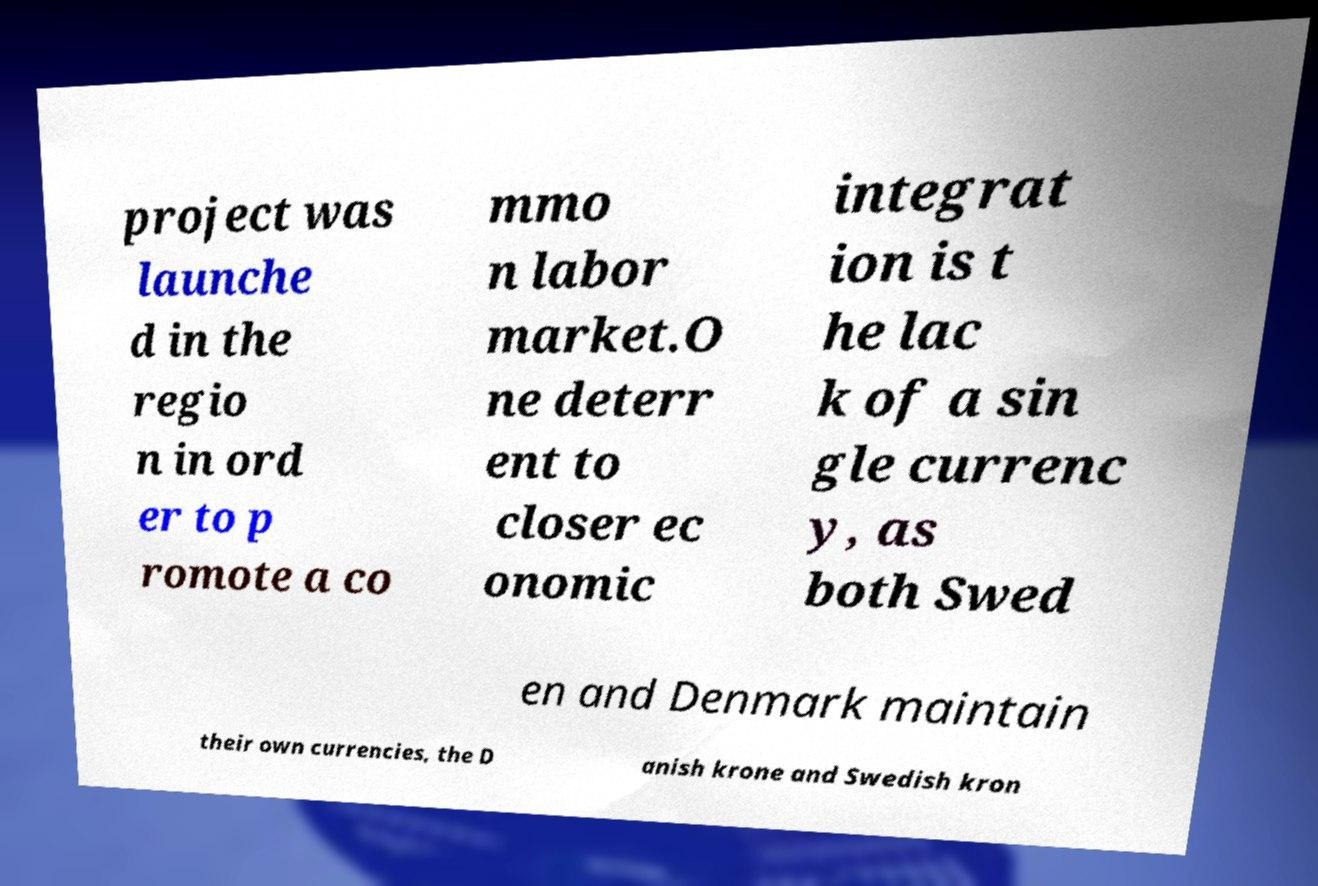Can you read and provide the text displayed in the image?This photo seems to have some interesting text. Can you extract and type it out for me? project was launche d in the regio n in ord er to p romote a co mmo n labor market.O ne deterr ent to closer ec onomic integrat ion is t he lac k of a sin gle currenc y, as both Swed en and Denmark maintain their own currencies, the D anish krone and Swedish kron 